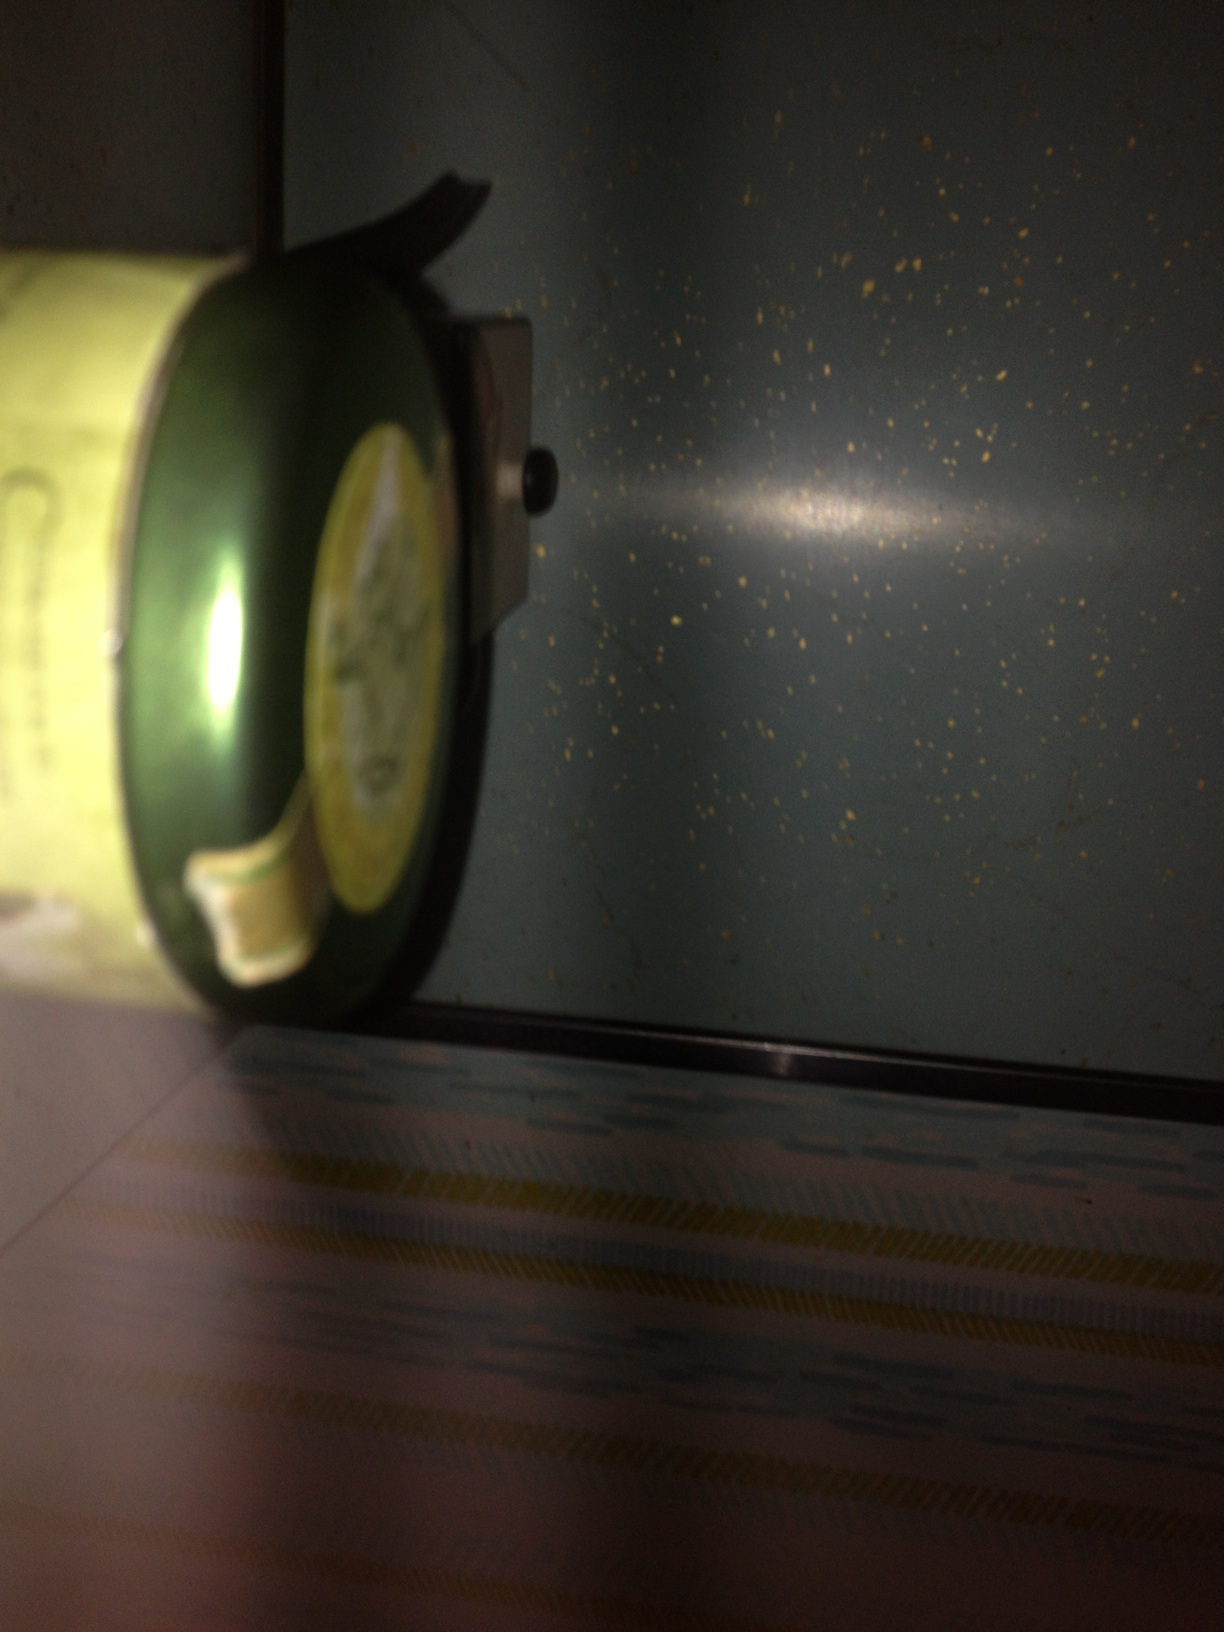What is this can? I'm not sure what kind of tea it is. The image shows a can with a label that suggests it could be a type of drink, possibly tea. It appears greenish and might be related to green tea or any other herbal variant. Unfortunately, the specifics of the tea or drink cannot be determined precisely from this image alone. 